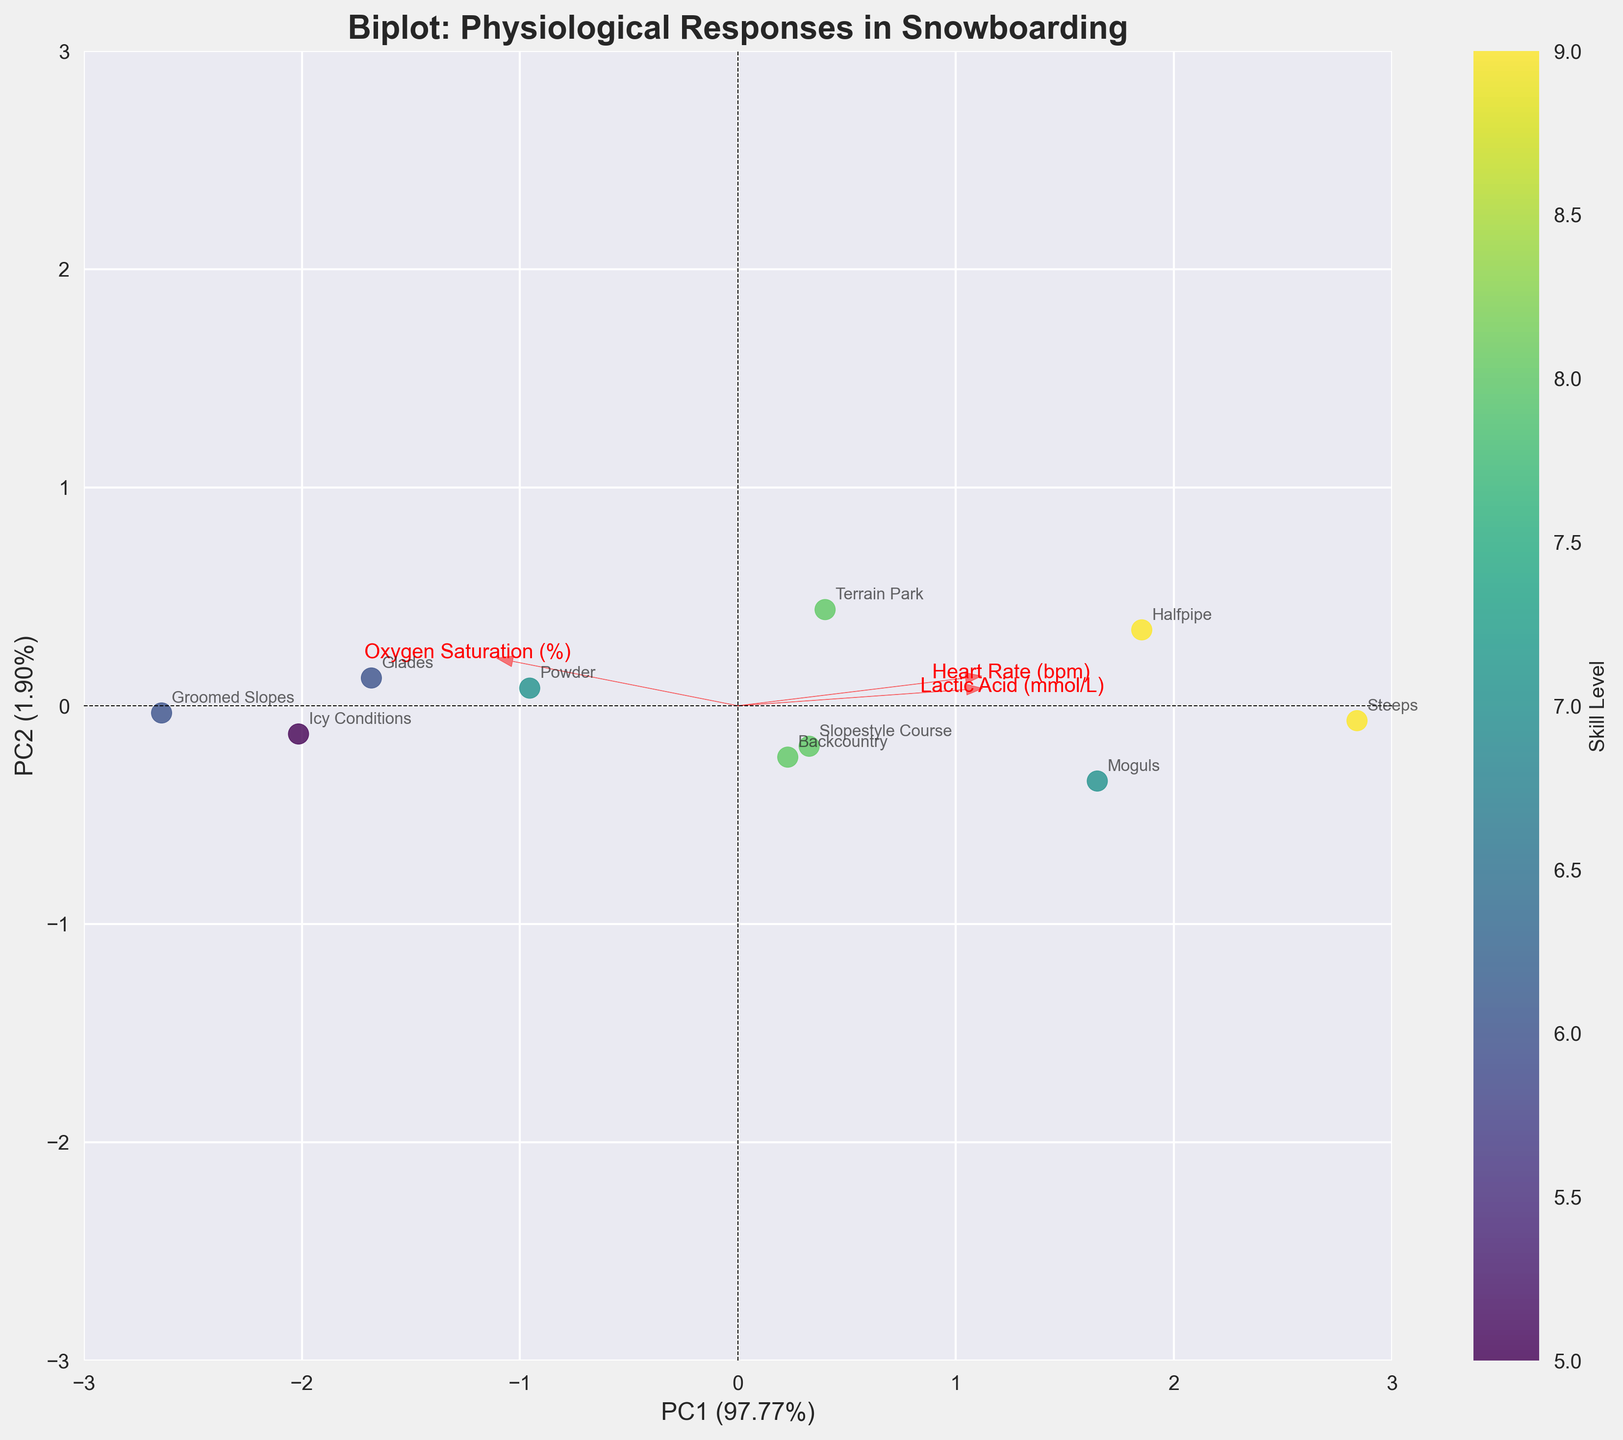How many terrains are compared in the figure? Count the number of distinct data points labeled with different terrains in the plot.
Answer: 10 What is the title of the biplot? Read the text at the top of the figure that describes the main subject of the biplot.
Answer: Biplot: Physiological Responses in Snowboarding Which terrain has the highest skill level? Identify the data point labeled with the highest value on the colorbar, which represents skill level.
Answer: Halfpipe What are the PC1 and PC2 percentages in the biplot? These percentages are typically shown on the axes labels. Read the x-axis label for PC1 and the y-axis label for PC2.
Answer: 55.31% and 30.69% Which feature vector has the largest loading on PC1? Look at the arrows representing feature vectors and compare their lengths along the PC1 axis; find the one closest to 1 or -1.
Answer: Heart Rate (bpm) Which terrain has the lowest oxygen saturation? Find the terrain with the data point located most negatively along the feature vector for "Oxygen Saturation (%)".
Answer: Steeps How do the physiological responses on the "Halfpipe" compare to "Groomed Slopes"? Assess the position of their respective data points in terms of PC1 and PC2, as well as their proximity to different feature vectors.
Answer: Halfpipe has higher heart rate and lactic acid, lower oxygen saturation Which features appear most strongly correlated with skill level? Examine the direction in which data points shift as the skill level color changes, particularly looking at the projection of data points along feature vectors.
Answer: Heart Rate (bpm) and Lactic Acid (mmol/L) What is the relationship between Heart Rate and Oxygen Saturation across the terrains? Compare the directions and lengths of the feature vectors for "Heart Rate (bpm)" and "Oxygen Saturation (%)" to infer their correlation.
Answer: Generally inverse (negative correlation) 